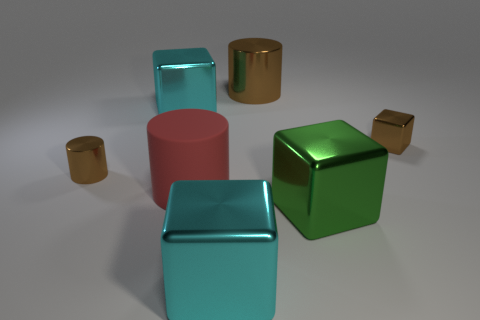Subtract 1 cubes. How many cubes are left? 3 Add 3 large cyan metal cubes. How many objects exist? 10 Subtract all cylinders. How many objects are left? 4 Subtract all brown cubes. Subtract all rubber cylinders. How many objects are left? 5 Add 5 large red matte objects. How many large red matte objects are left? 6 Add 2 small brown metal things. How many small brown metal things exist? 4 Subtract 0 gray blocks. How many objects are left? 7 